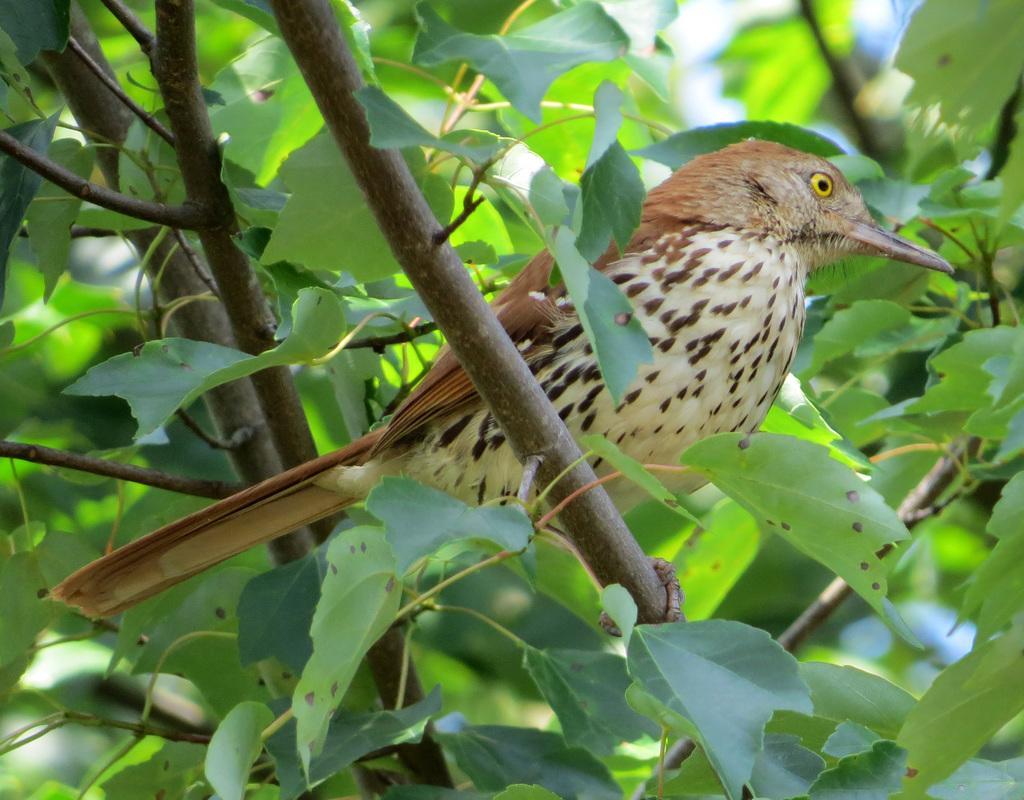Could you give a brief overview of what you see in this image? In this image I can see a bird on the trees. The bird is in brown and cream color. 